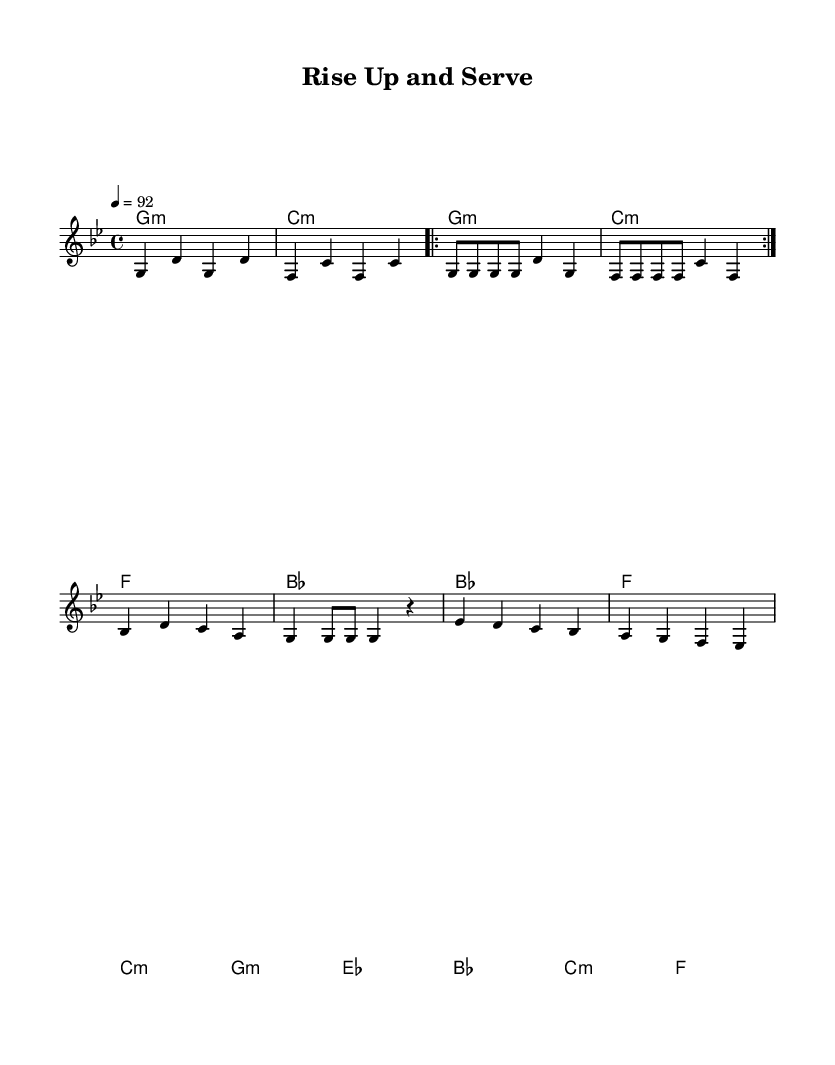What is the key signature of this music? The key signature is G minor, which has two flats (B flat and E flat). This can be determined by looking at the key signature indicated at the beginning of the staff.
Answer: G minor What is the time signature of this piece? The time signature is 4/4, indicating four beats per measure. This can be identified by the 4 over 4 marker at the beginning of the sheet music, which denotes the number of beats in each measure.
Answer: 4/4 What is the tempo marking for this piece? The tempo marking is 92 beats per minute, as indicated at the beginning of the music after the tempo designation.
Answer: 92 How many measures are in the chorus section? The chorus has 4 measures, as counted in the measures marked by the chord changes in the labeled section of the sheet music.
Answer: 4 What is the first line of lyrics in the verse? The first line of the lyrics in the verse is "Step up, reach out, it's time to make a change." This can be found in the lyrics section aligned with the melody notes.
Answer: Step up, reach out, it's time to make a change How does the melody change between the verse and the chorus? The verse melody consists of a repeated rhythmic pattern, while the chorus introduces a different melodic line that focuses on community action, suggesting a shift in energy. The difference in note selection and rhythm reflects a transition in thematic content between verses and the chorus.
Answer: Different melodic line What does the phrase "Rise up and serve" emphasize in the chorus? The phrase emphasizes the call to action and community engagement, central to the theme of volunteering and activism present throughout the piece. It captures the spirit of collective effort and motivation conveyed in this rap.
Answer: Call to action 